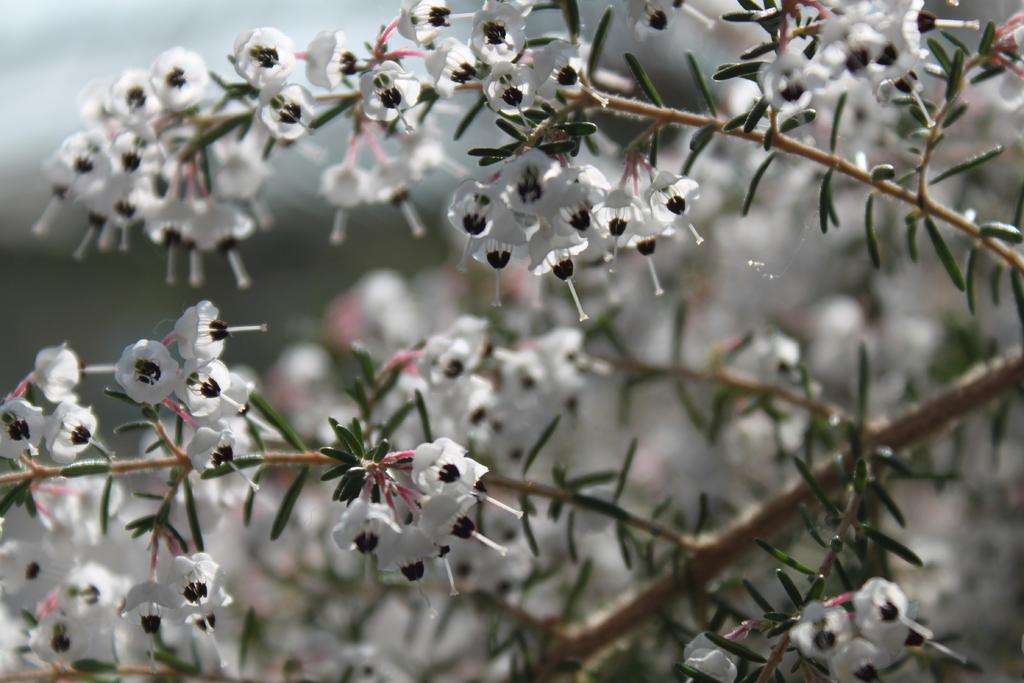What type of plant life is present in the image? There are white flowers, leaves, and stems in the image. Can you describe the appearance of the flowers? The flowers are white in color. What else can be seen in the image besides the flowers? There are leaves and stems visible in the image. How would you describe the background of the image? The background of the image is blurry. What type of cable can be seen hanging from the flowers in the image? There is no cable present in the image; it features white flowers, leaves, and stems with a blurry background. 